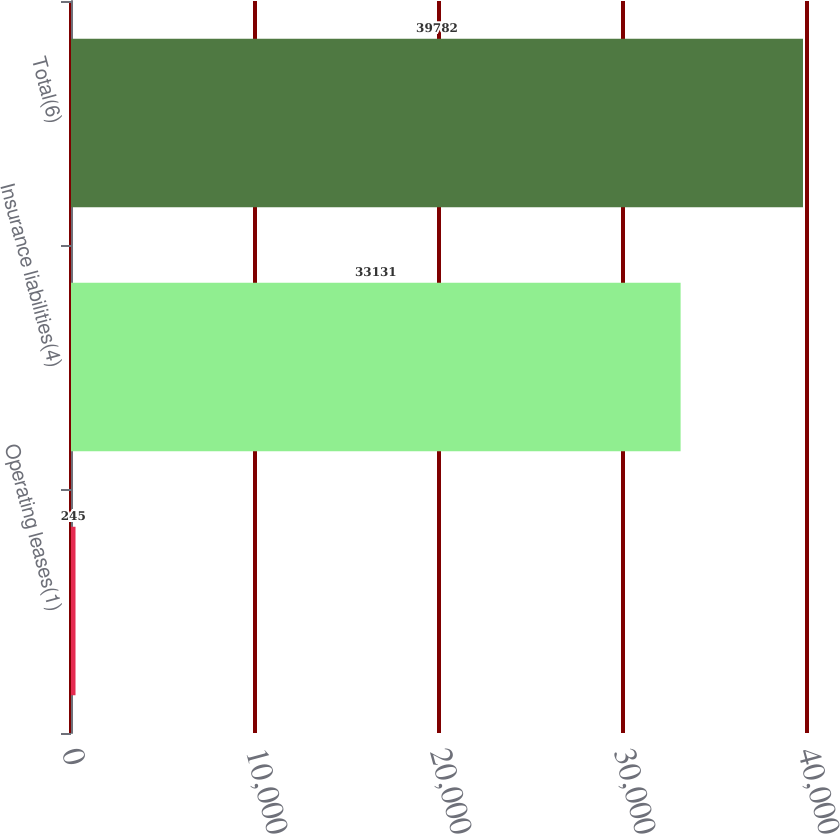Convert chart. <chart><loc_0><loc_0><loc_500><loc_500><bar_chart><fcel>Operating leases(1)<fcel>Insurance liabilities(4)<fcel>Total(6)<nl><fcel>245<fcel>33131<fcel>39782<nl></chart> 